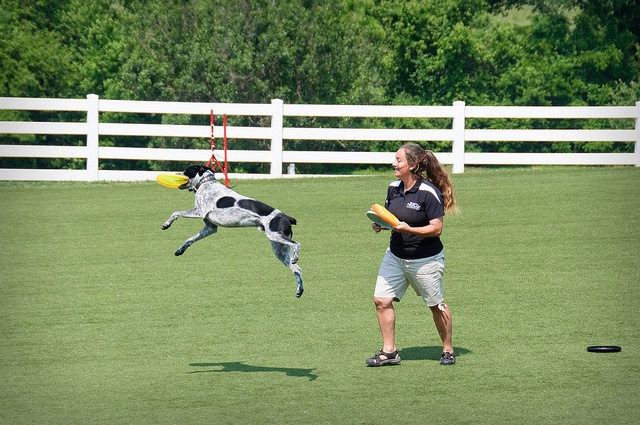Describe the objects in this image and their specific colors. I can see people in black, gray, lightgray, and darkgray tones, dog in black, lightgray, darkgray, and gray tones, frisbee in black, khaki, and teal tones, frisbee in black, khaki, and gold tones, and frisbee in black, darkgreen, and gray tones in this image. 